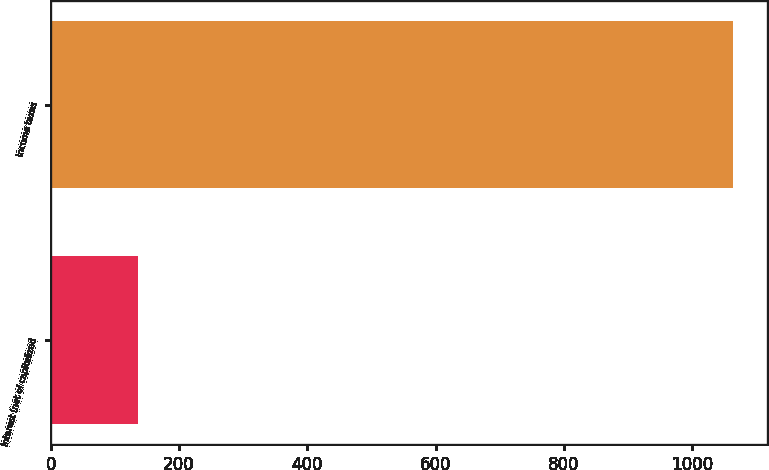Convert chart. <chart><loc_0><loc_0><loc_500><loc_500><bar_chart><fcel>Interest (net of capitalized<fcel>Income taxes<nl><fcel>136<fcel>1064<nl></chart> 